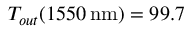Convert formula to latex. <formula><loc_0><loc_0><loc_500><loc_500>T _ { o u t } ( 1 5 5 0 \, n m ) = 9 9 . 7 \, \</formula> 